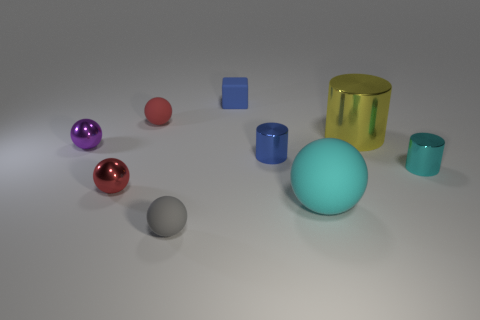There is a cylinder that is the same color as the cube; what is it made of?
Your answer should be compact. Metal. The rubber object that is left of the gray matte sphere that is left of the large cyan rubber sphere is what color?
Offer a very short reply. Red. Is the size of the purple shiny thing the same as the blue rubber thing?
Provide a succinct answer. Yes. What material is the cyan object that is the same shape as the yellow metallic object?
Provide a succinct answer. Metal. What number of red matte balls are the same size as the gray rubber ball?
Provide a short and direct response. 1. There is a large thing that is the same material as the block; what is its color?
Offer a terse response. Cyan. Are there fewer tiny purple metal things than shiny cylinders?
Make the answer very short. Yes. How many yellow things are either metal cylinders or tiny metallic objects?
Offer a very short reply. 1. How many small things are both behind the cyan metal object and to the right of the gray sphere?
Keep it short and to the point. 2. Are the big cyan ball and the tiny purple object made of the same material?
Give a very brief answer. No. 